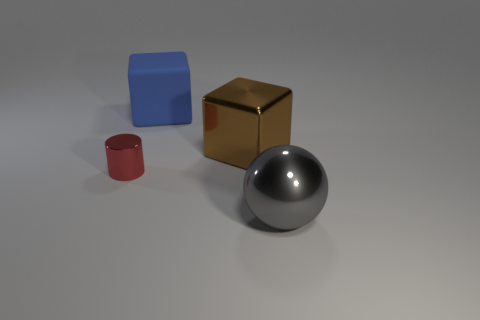Are there any other things that have the same size as the cylinder?
Your answer should be very brief. No. What number of other objects are the same color as the metallic sphere?
Your answer should be very brief. 0. What number of cylinders are large brown things or gray things?
Provide a short and direct response. 0. There is a object that is in front of the object that is on the left side of the rubber object; what is its color?
Provide a short and direct response. Gray. There is a brown metallic object; what shape is it?
Make the answer very short. Cube. Do the thing in front of the red object and the large metallic cube have the same size?
Make the answer very short. Yes. Are there any small cubes that have the same material as the tiny thing?
Keep it short and to the point. No. How many objects are either large objects behind the gray sphere or large green cubes?
Ensure brevity in your answer.  2. Are any big purple matte cylinders visible?
Offer a very short reply. No. The thing that is behind the red cylinder and to the left of the brown metallic block has what shape?
Make the answer very short. Cube. 